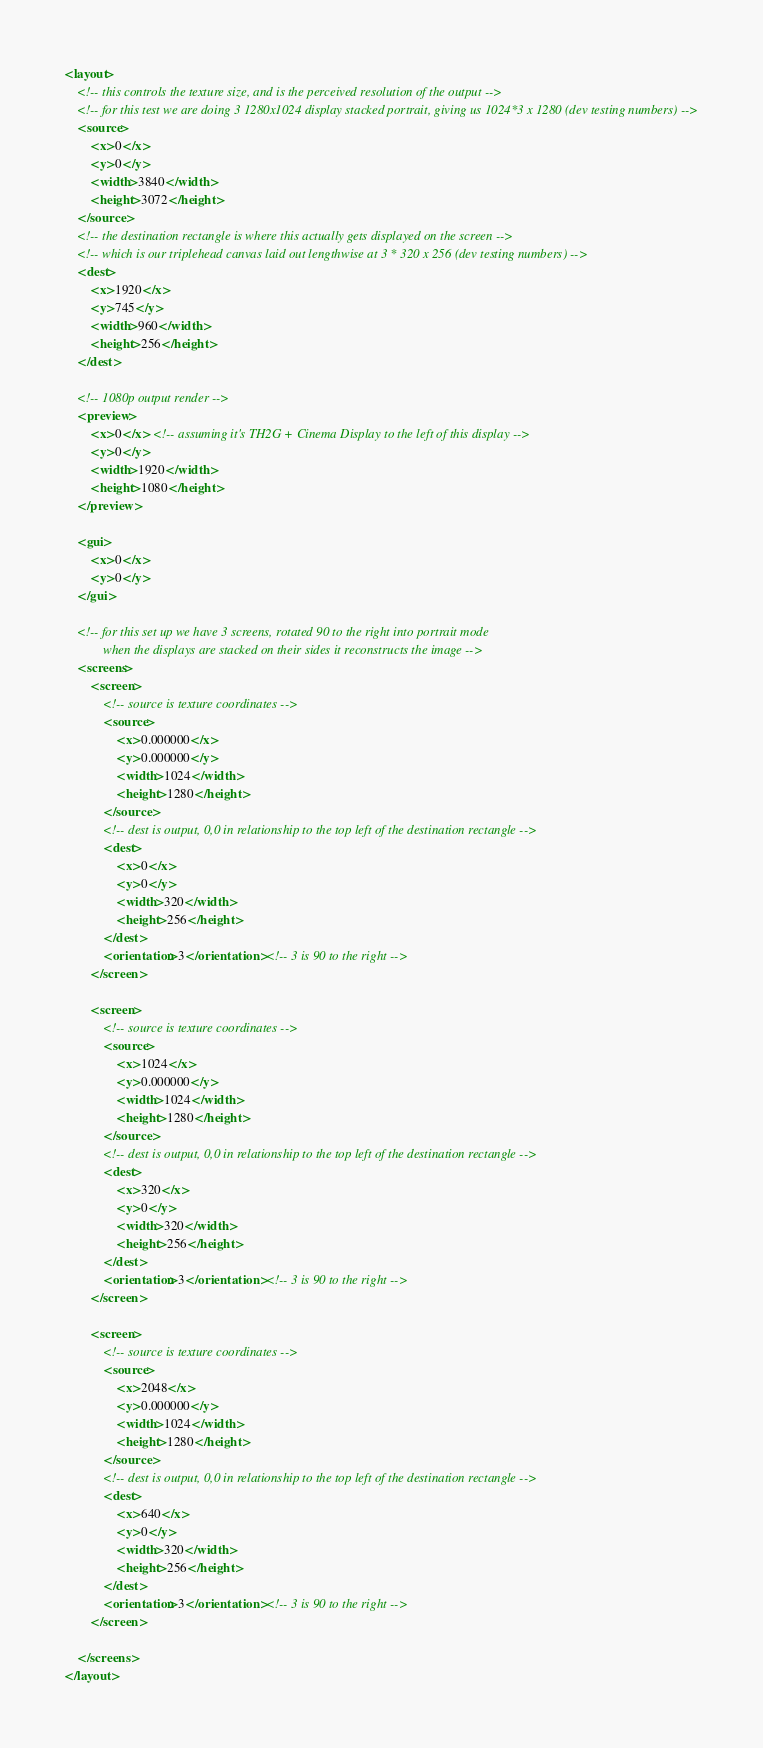Convert code to text. <code><loc_0><loc_0><loc_500><loc_500><_XML_><layout>
	<!-- this controls the texture size, and is the perceived resolution of the output -->
	<!-- for this test we are doing 3 1280x1024 display stacked portrait, giving us 1024*3 x 1280 (dev testing numbers) -->
    <source>
        <x>0</x>
        <y>0</y>
        <width>3840</width>
        <height>3072</height>
    </source>
	<!-- the destination rectangle is where this actually gets displayed on the screen -->
	<!-- which is our triplehead canvas laid out lengthwise at 3 * 320 x 256 (dev testing numbers) -->
    <dest>
        <x>1920</x>
        <y>745</y>
        <width>960</width>
        <height>256</height>
    </dest>

	<!-- 1080p output render -->
    <preview>
        <x>0</x> <!-- assuming it's TH2G + Cinema Display to the left of this display -->
        <y>0</y>
        <width>1920</width>
        <height>1080</height>
    </preview>

	<gui>
		<x>0</x>
		<y>0</y>
	</gui>
	
	<!-- for this set up we have 3 screens, rotated 90 to the right into portrait mode
	 		when the displays are stacked on their sides it reconstructs the image -->
    <screens>
        <screen>
			<!-- source is texture coordinates -->
            <source>
                <x>0.000000</x>
                <y>0.000000</y>
                <width>1024</width>
                <height>1280</height>
            </source>
			<!-- dest is output, 0,0 in relationship to the top left of the destination rectangle -->
            <dest>
                <x>0</x>
                <y>0</y>
                <width>320</width>
                <height>256</height>
            </dest>
	        <orientation>3</orientation> <!-- 3 is 90 to the right -->
        </screen>

        <screen>
			<!-- source is texture coordinates -->
            <source>
                <x>1024</x>
                <y>0.000000</y>
                <width>1024</width>
                <height>1280</height>
            </source>
			<!-- dest is output, 0,0 in relationship to the top left of the destination rectangle -->
            <dest>
                <x>320</x>
                <y>0</y>
                <width>320</width>
                <height>256</height>
            </dest>
	        <orientation>3</orientation> <!-- 3 is 90 to the right -->
        </screen>

        <screen>
			<!-- source is texture coordinates -->
            <source>
                <x>2048</x>
                <y>0.000000</y>
                <width>1024</width>
                <height>1280</height>
            </source>
			<!-- dest is output, 0,0 in relationship to the top left of the destination rectangle -->
            <dest>
                <x>640</x>
                <y>0</y>
                <width>320</width>
                <height>256</height>
            </dest>
	        <orientation>3</orientation> <!-- 3 is 90 to the right -->
        </screen>

    </screens>
</layout>
</code> 